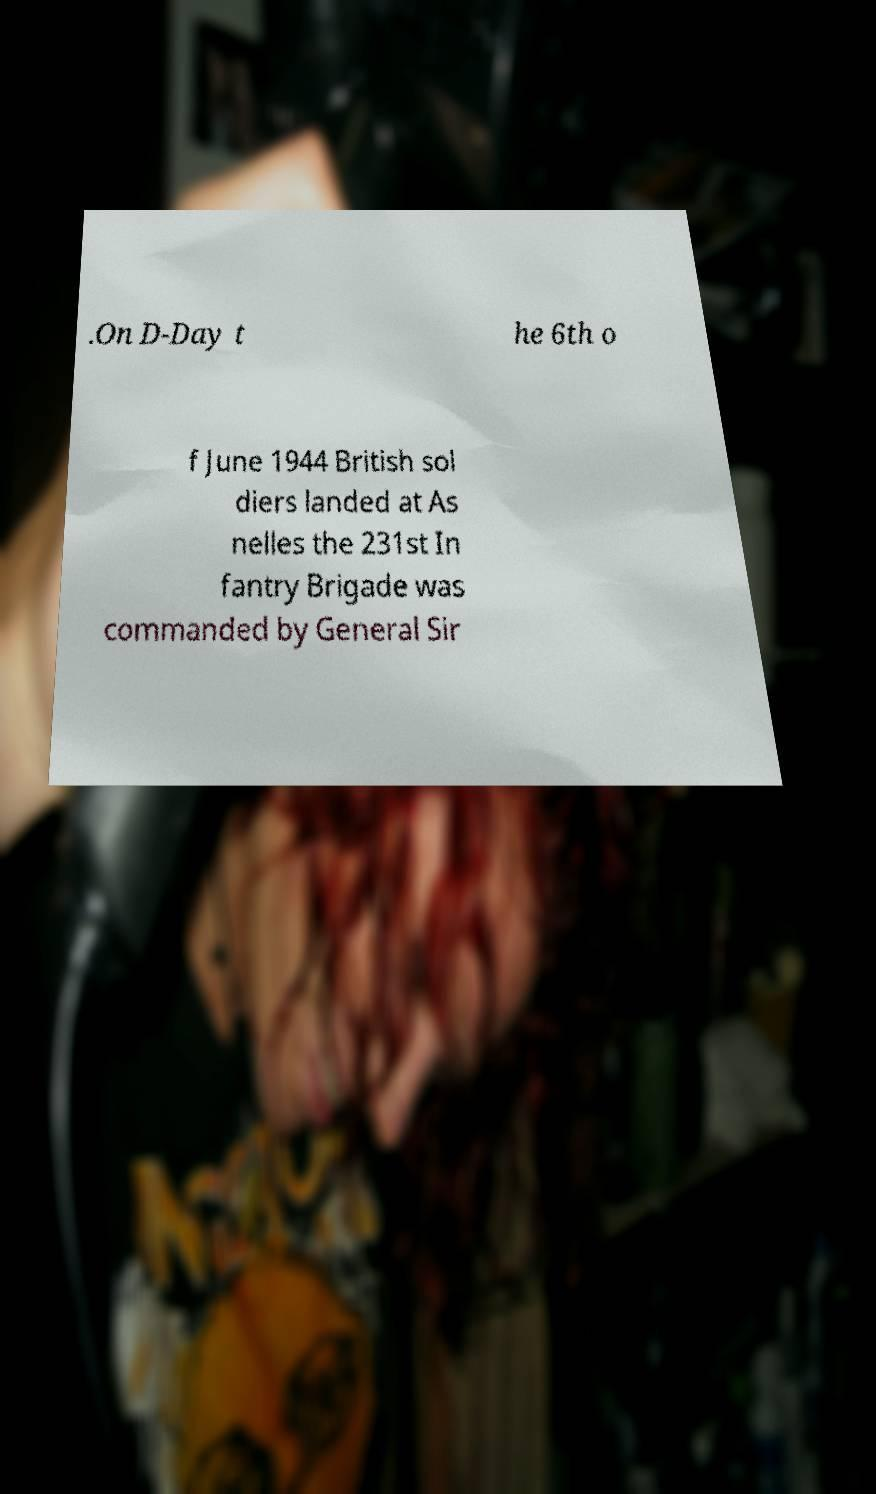Please identify and transcribe the text found in this image. .On D-Day t he 6th o f June 1944 British sol diers landed at As nelles the 231st In fantry Brigade was commanded by General Sir 